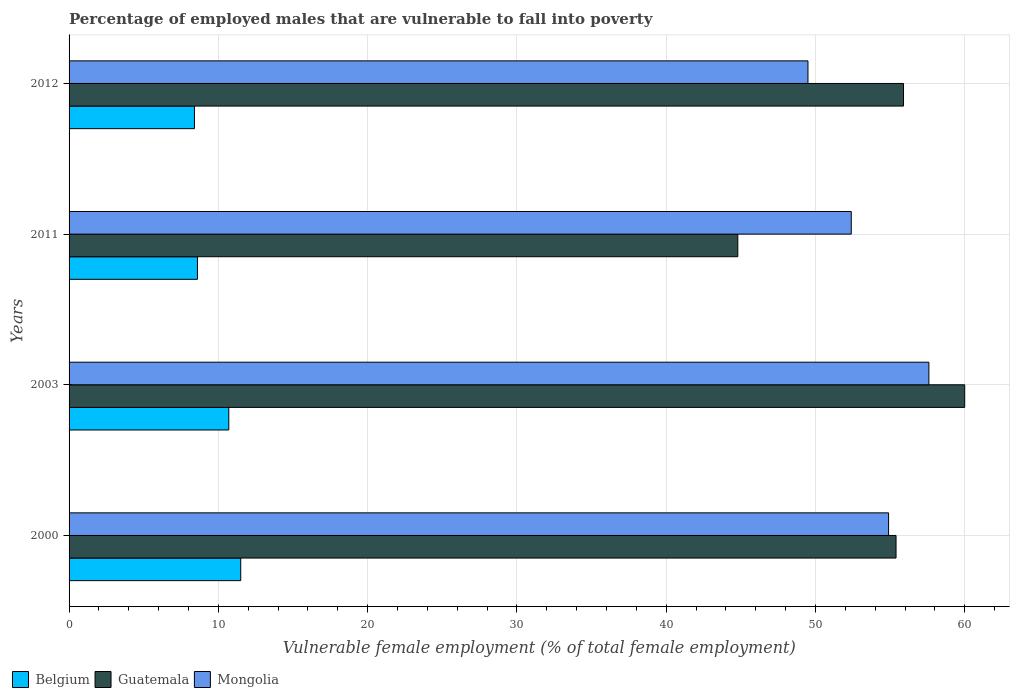How many different coloured bars are there?
Offer a terse response. 3. Are the number of bars per tick equal to the number of legend labels?
Keep it short and to the point. Yes. How many bars are there on the 1st tick from the bottom?
Offer a very short reply. 3. What is the percentage of employed males who are vulnerable to fall into poverty in Belgium in 2012?
Give a very brief answer. 8.4. Across all years, what is the minimum percentage of employed males who are vulnerable to fall into poverty in Belgium?
Offer a terse response. 8.4. In which year was the percentage of employed males who are vulnerable to fall into poverty in Guatemala maximum?
Ensure brevity in your answer.  2003. What is the total percentage of employed males who are vulnerable to fall into poverty in Belgium in the graph?
Offer a very short reply. 39.2. What is the difference between the percentage of employed males who are vulnerable to fall into poverty in Mongolia in 2003 and that in 2012?
Provide a succinct answer. 8.1. What is the difference between the percentage of employed males who are vulnerable to fall into poverty in Belgium in 2000 and the percentage of employed males who are vulnerable to fall into poverty in Guatemala in 2012?
Provide a succinct answer. -44.4. What is the average percentage of employed males who are vulnerable to fall into poverty in Belgium per year?
Your response must be concise. 9.8. In the year 2012, what is the difference between the percentage of employed males who are vulnerable to fall into poverty in Belgium and percentage of employed males who are vulnerable to fall into poverty in Mongolia?
Keep it short and to the point. -41.1. In how many years, is the percentage of employed males who are vulnerable to fall into poverty in Belgium greater than 16 %?
Give a very brief answer. 0. What is the ratio of the percentage of employed males who are vulnerable to fall into poverty in Belgium in 2011 to that in 2012?
Provide a succinct answer. 1.02. Is the difference between the percentage of employed males who are vulnerable to fall into poverty in Belgium in 2000 and 2012 greater than the difference between the percentage of employed males who are vulnerable to fall into poverty in Mongolia in 2000 and 2012?
Offer a very short reply. No. What is the difference between the highest and the second highest percentage of employed males who are vulnerable to fall into poverty in Guatemala?
Your answer should be very brief. 4.1. What is the difference between the highest and the lowest percentage of employed males who are vulnerable to fall into poverty in Belgium?
Your response must be concise. 3.1. Is the sum of the percentage of employed males who are vulnerable to fall into poverty in Guatemala in 2003 and 2012 greater than the maximum percentage of employed males who are vulnerable to fall into poverty in Mongolia across all years?
Offer a very short reply. Yes. What does the 1st bar from the top in 2003 represents?
Provide a short and direct response. Mongolia. What does the 1st bar from the bottom in 2012 represents?
Provide a succinct answer. Belgium. How many bars are there?
Provide a succinct answer. 12. How many years are there in the graph?
Ensure brevity in your answer.  4. Are the values on the major ticks of X-axis written in scientific E-notation?
Offer a terse response. No. Does the graph contain grids?
Your response must be concise. Yes. Where does the legend appear in the graph?
Provide a succinct answer. Bottom left. How are the legend labels stacked?
Ensure brevity in your answer.  Horizontal. What is the title of the graph?
Give a very brief answer. Percentage of employed males that are vulnerable to fall into poverty. Does "Equatorial Guinea" appear as one of the legend labels in the graph?
Give a very brief answer. No. What is the label or title of the X-axis?
Ensure brevity in your answer.  Vulnerable female employment (% of total female employment). What is the label or title of the Y-axis?
Ensure brevity in your answer.  Years. What is the Vulnerable female employment (% of total female employment) of Belgium in 2000?
Your answer should be very brief. 11.5. What is the Vulnerable female employment (% of total female employment) in Guatemala in 2000?
Give a very brief answer. 55.4. What is the Vulnerable female employment (% of total female employment) in Mongolia in 2000?
Offer a very short reply. 54.9. What is the Vulnerable female employment (% of total female employment) of Belgium in 2003?
Keep it short and to the point. 10.7. What is the Vulnerable female employment (% of total female employment) in Mongolia in 2003?
Offer a terse response. 57.6. What is the Vulnerable female employment (% of total female employment) of Belgium in 2011?
Give a very brief answer. 8.6. What is the Vulnerable female employment (% of total female employment) in Guatemala in 2011?
Provide a succinct answer. 44.8. What is the Vulnerable female employment (% of total female employment) of Mongolia in 2011?
Give a very brief answer. 52.4. What is the Vulnerable female employment (% of total female employment) of Belgium in 2012?
Provide a short and direct response. 8.4. What is the Vulnerable female employment (% of total female employment) of Guatemala in 2012?
Offer a very short reply. 55.9. What is the Vulnerable female employment (% of total female employment) of Mongolia in 2012?
Your answer should be very brief. 49.5. Across all years, what is the maximum Vulnerable female employment (% of total female employment) of Belgium?
Offer a very short reply. 11.5. Across all years, what is the maximum Vulnerable female employment (% of total female employment) in Mongolia?
Your answer should be compact. 57.6. Across all years, what is the minimum Vulnerable female employment (% of total female employment) of Belgium?
Ensure brevity in your answer.  8.4. Across all years, what is the minimum Vulnerable female employment (% of total female employment) in Guatemala?
Provide a short and direct response. 44.8. Across all years, what is the minimum Vulnerable female employment (% of total female employment) of Mongolia?
Provide a succinct answer. 49.5. What is the total Vulnerable female employment (% of total female employment) in Belgium in the graph?
Keep it short and to the point. 39.2. What is the total Vulnerable female employment (% of total female employment) of Guatemala in the graph?
Your answer should be very brief. 216.1. What is the total Vulnerable female employment (% of total female employment) in Mongolia in the graph?
Provide a succinct answer. 214.4. What is the difference between the Vulnerable female employment (% of total female employment) in Belgium in 2000 and that in 2003?
Give a very brief answer. 0.8. What is the difference between the Vulnerable female employment (% of total female employment) in Guatemala in 2000 and that in 2003?
Your answer should be compact. -4.6. What is the difference between the Vulnerable female employment (% of total female employment) in Mongolia in 2000 and that in 2003?
Make the answer very short. -2.7. What is the difference between the Vulnerable female employment (% of total female employment) of Mongolia in 2000 and that in 2011?
Your answer should be very brief. 2.5. What is the difference between the Vulnerable female employment (% of total female employment) of Belgium in 2000 and that in 2012?
Ensure brevity in your answer.  3.1. What is the difference between the Vulnerable female employment (% of total female employment) of Mongolia in 2003 and that in 2011?
Your response must be concise. 5.2. What is the difference between the Vulnerable female employment (% of total female employment) of Belgium in 2003 and that in 2012?
Keep it short and to the point. 2.3. What is the difference between the Vulnerable female employment (% of total female employment) of Mongolia in 2003 and that in 2012?
Offer a terse response. 8.1. What is the difference between the Vulnerable female employment (% of total female employment) in Belgium in 2011 and that in 2012?
Offer a very short reply. 0.2. What is the difference between the Vulnerable female employment (% of total female employment) of Belgium in 2000 and the Vulnerable female employment (% of total female employment) of Guatemala in 2003?
Your answer should be very brief. -48.5. What is the difference between the Vulnerable female employment (% of total female employment) in Belgium in 2000 and the Vulnerable female employment (% of total female employment) in Mongolia in 2003?
Your answer should be very brief. -46.1. What is the difference between the Vulnerable female employment (% of total female employment) of Guatemala in 2000 and the Vulnerable female employment (% of total female employment) of Mongolia in 2003?
Make the answer very short. -2.2. What is the difference between the Vulnerable female employment (% of total female employment) of Belgium in 2000 and the Vulnerable female employment (% of total female employment) of Guatemala in 2011?
Your answer should be compact. -33.3. What is the difference between the Vulnerable female employment (% of total female employment) of Belgium in 2000 and the Vulnerable female employment (% of total female employment) of Mongolia in 2011?
Ensure brevity in your answer.  -40.9. What is the difference between the Vulnerable female employment (% of total female employment) of Belgium in 2000 and the Vulnerable female employment (% of total female employment) of Guatemala in 2012?
Offer a terse response. -44.4. What is the difference between the Vulnerable female employment (% of total female employment) of Belgium in 2000 and the Vulnerable female employment (% of total female employment) of Mongolia in 2012?
Keep it short and to the point. -38. What is the difference between the Vulnerable female employment (% of total female employment) in Belgium in 2003 and the Vulnerable female employment (% of total female employment) in Guatemala in 2011?
Provide a short and direct response. -34.1. What is the difference between the Vulnerable female employment (% of total female employment) of Belgium in 2003 and the Vulnerable female employment (% of total female employment) of Mongolia in 2011?
Your response must be concise. -41.7. What is the difference between the Vulnerable female employment (% of total female employment) of Belgium in 2003 and the Vulnerable female employment (% of total female employment) of Guatemala in 2012?
Make the answer very short. -45.2. What is the difference between the Vulnerable female employment (% of total female employment) in Belgium in 2003 and the Vulnerable female employment (% of total female employment) in Mongolia in 2012?
Provide a short and direct response. -38.8. What is the difference between the Vulnerable female employment (% of total female employment) of Guatemala in 2003 and the Vulnerable female employment (% of total female employment) of Mongolia in 2012?
Your answer should be compact. 10.5. What is the difference between the Vulnerable female employment (% of total female employment) of Belgium in 2011 and the Vulnerable female employment (% of total female employment) of Guatemala in 2012?
Give a very brief answer. -47.3. What is the difference between the Vulnerable female employment (% of total female employment) in Belgium in 2011 and the Vulnerable female employment (% of total female employment) in Mongolia in 2012?
Ensure brevity in your answer.  -40.9. What is the average Vulnerable female employment (% of total female employment) of Guatemala per year?
Provide a succinct answer. 54.02. What is the average Vulnerable female employment (% of total female employment) of Mongolia per year?
Offer a very short reply. 53.6. In the year 2000, what is the difference between the Vulnerable female employment (% of total female employment) in Belgium and Vulnerable female employment (% of total female employment) in Guatemala?
Ensure brevity in your answer.  -43.9. In the year 2000, what is the difference between the Vulnerable female employment (% of total female employment) of Belgium and Vulnerable female employment (% of total female employment) of Mongolia?
Offer a terse response. -43.4. In the year 2000, what is the difference between the Vulnerable female employment (% of total female employment) of Guatemala and Vulnerable female employment (% of total female employment) of Mongolia?
Offer a very short reply. 0.5. In the year 2003, what is the difference between the Vulnerable female employment (% of total female employment) of Belgium and Vulnerable female employment (% of total female employment) of Guatemala?
Ensure brevity in your answer.  -49.3. In the year 2003, what is the difference between the Vulnerable female employment (% of total female employment) of Belgium and Vulnerable female employment (% of total female employment) of Mongolia?
Provide a short and direct response. -46.9. In the year 2011, what is the difference between the Vulnerable female employment (% of total female employment) in Belgium and Vulnerable female employment (% of total female employment) in Guatemala?
Give a very brief answer. -36.2. In the year 2011, what is the difference between the Vulnerable female employment (% of total female employment) of Belgium and Vulnerable female employment (% of total female employment) of Mongolia?
Your response must be concise. -43.8. In the year 2011, what is the difference between the Vulnerable female employment (% of total female employment) in Guatemala and Vulnerable female employment (% of total female employment) in Mongolia?
Your response must be concise. -7.6. In the year 2012, what is the difference between the Vulnerable female employment (% of total female employment) in Belgium and Vulnerable female employment (% of total female employment) in Guatemala?
Provide a succinct answer. -47.5. In the year 2012, what is the difference between the Vulnerable female employment (% of total female employment) of Belgium and Vulnerable female employment (% of total female employment) of Mongolia?
Ensure brevity in your answer.  -41.1. What is the ratio of the Vulnerable female employment (% of total female employment) in Belgium in 2000 to that in 2003?
Give a very brief answer. 1.07. What is the ratio of the Vulnerable female employment (% of total female employment) in Guatemala in 2000 to that in 2003?
Make the answer very short. 0.92. What is the ratio of the Vulnerable female employment (% of total female employment) of Mongolia in 2000 to that in 2003?
Your answer should be compact. 0.95. What is the ratio of the Vulnerable female employment (% of total female employment) of Belgium in 2000 to that in 2011?
Keep it short and to the point. 1.34. What is the ratio of the Vulnerable female employment (% of total female employment) of Guatemala in 2000 to that in 2011?
Offer a very short reply. 1.24. What is the ratio of the Vulnerable female employment (% of total female employment) of Mongolia in 2000 to that in 2011?
Ensure brevity in your answer.  1.05. What is the ratio of the Vulnerable female employment (% of total female employment) of Belgium in 2000 to that in 2012?
Offer a terse response. 1.37. What is the ratio of the Vulnerable female employment (% of total female employment) in Guatemala in 2000 to that in 2012?
Offer a very short reply. 0.99. What is the ratio of the Vulnerable female employment (% of total female employment) of Mongolia in 2000 to that in 2012?
Give a very brief answer. 1.11. What is the ratio of the Vulnerable female employment (% of total female employment) in Belgium in 2003 to that in 2011?
Your response must be concise. 1.24. What is the ratio of the Vulnerable female employment (% of total female employment) in Guatemala in 2003 to that in 2011?
Ensure brevity in your answer.  1.34. What is the ratio of the Vulnerable female employment (% of total female employment) in Mongolia in 2003 to that in 2011?
Provide a succinct answer. 1.1. What is the ratio of the Vulnerable female employment (% of total female employment) in Belgium in 2003 to that in 2012?
Your answer should be very brief. 1.27. What is the ratio of the Vulnerable female employment (% of total female employment) in Guatemala in 2003 to that in 2012?
Make the answer very short. 1.07. What is the ratio of the Vulnerable female employment (% of total female employment) in Mongolia in 2003 to that in 2012?
Make the answer very short. 1.16. What is the ratio of the Vulnerable female employment (% of total female employment) of Belgium in 2011 to that in 2012?
Give a very brief answer. 1.02. What is the ratio of the Vulnerable female employment (% of total female employment) of Guatemala in 2011 to that in 2012?
Give a very brief answer. 0.8. What is the ratio of the Vulnerable female employment (% of total female employment) of Mongolia in 2011 to that in 2012?
Your answer should be compact. 1.06. What is the difference between the highest and the second highest Vulnerable female employment (% of total female employment) in Belgium?
Provide a succinct answer. 0.8. What is the difference between the highest and the lowest Vulnerable female employment (% of total female employment) in Guatemala?
Offer a very short reply. 15.2. 